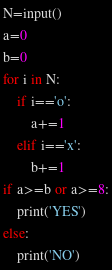<code> <loc_0><loc_0><loc_500><loc_500><_Python_>N=input()
a=0
b=0
for i in N:
    if i=='o':
        a+=1
    elif i=='x':
        b+=1
if a>=b or a>=8:
    print('YES')
else:
    print('NO')</code> 